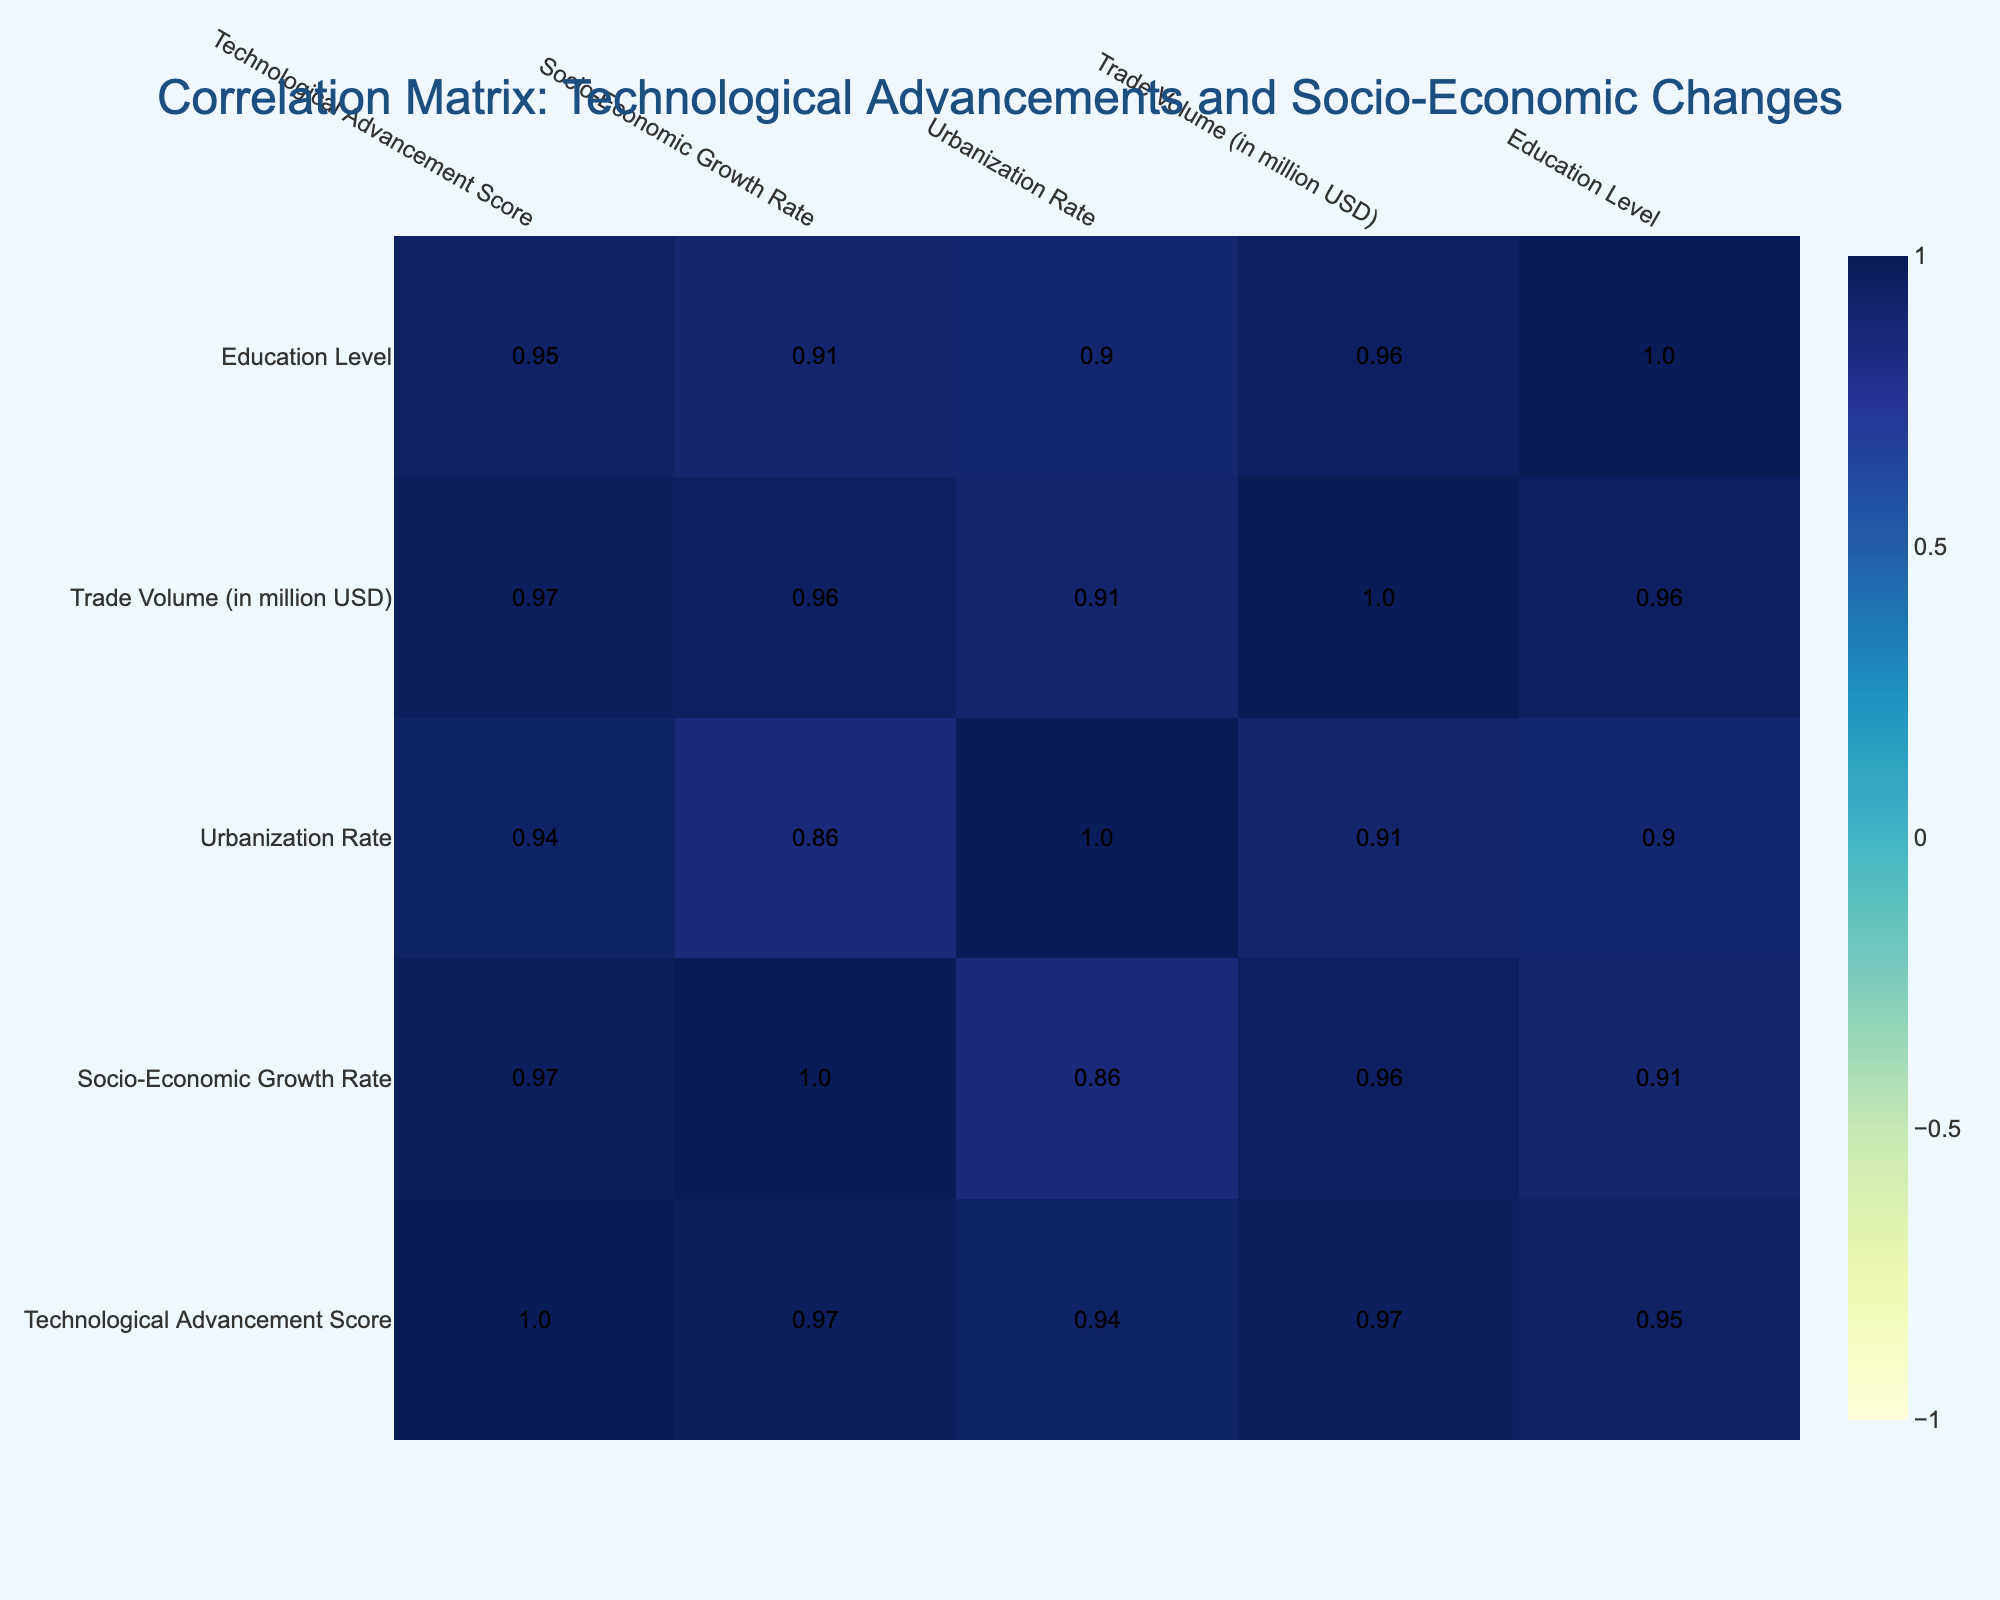What is the Technological Advancement Score of the British Empire? The Technological Advancement Score for the British Empire is listed directly in the table. By locating the British Empire row, we find that the score is 10.
Answer: 10 Which empire has the highest Soci0-Economic Growth Rate? Examining the Socio-Economic Growth Rate column, the British Empire has the highest score of 9 compared to other empires.
Answer: British Empire Is there a negative correlation between Education Level and Trade Volume in any empire? In the correlation table, we specifically look for the value correlating Education Level to Trade Volume. The values are positive which indicates there is no negative correlation.
Answer: No What is the average Urbanization Rate among all the empires? First, we sum the Urbanization Rates: (75 + 70 + 60 + 65 + 80 + 50 + 55 + 45 + 50 + 40) = 710. There are 10 empires, so we divide 710 by 10, resulting in an average Urbanization Rate of 71.
Answer: 71 Which empire had a lower Technological Advancement Score than its Urbanization Rate? From the table, we compare the Technological Advancement Scores to the Urbanization Rates. The Sassanian Empire has a score of 6 and an Urbanization Rate of 50, indicating it had a lower score than its rate.
Answer: Sassanian Empire Is the Technological Advancement Score for the Roman Empire equal to its Education Level? By comparing the values for the Roman Empire, the Technological Advancement Score is 8 and the Education Level is 60. These two scores are not equal.
Answer: No What is the difference in Trade Volume between the British Empire and the Inca Empire? Looking at the Trade Volume for both empires, the British Empire has a volume of 75 million USD and the Inca Empire has 15 million USD. The difference is 75 - 15 = 60 million USD.
Answer: 60 million USD Which empires have a Socio-Economic Growth Rate of 6 or higher? We filter the data by looking at the Socio-Economic Growth Rate column for scores of 6 or higher. These empires are: Roman Empire, Tang Dynasty, Mughal Empire, British Empire, and Qing Dynasty.
Answer: Roman Empire, Tang Dynasty, Mughal Empire, British Empire, Qing Dynasty What is the correlation coefficient between Trade Volume and Socio-Economic Growth Rate? We find the correlation coefficient value in the table that relates Trade Volume to Socio-Economic Growth Rate. This value is 0.88, indicating a strong positive correlation between the two variables.
Answer: 0.88 